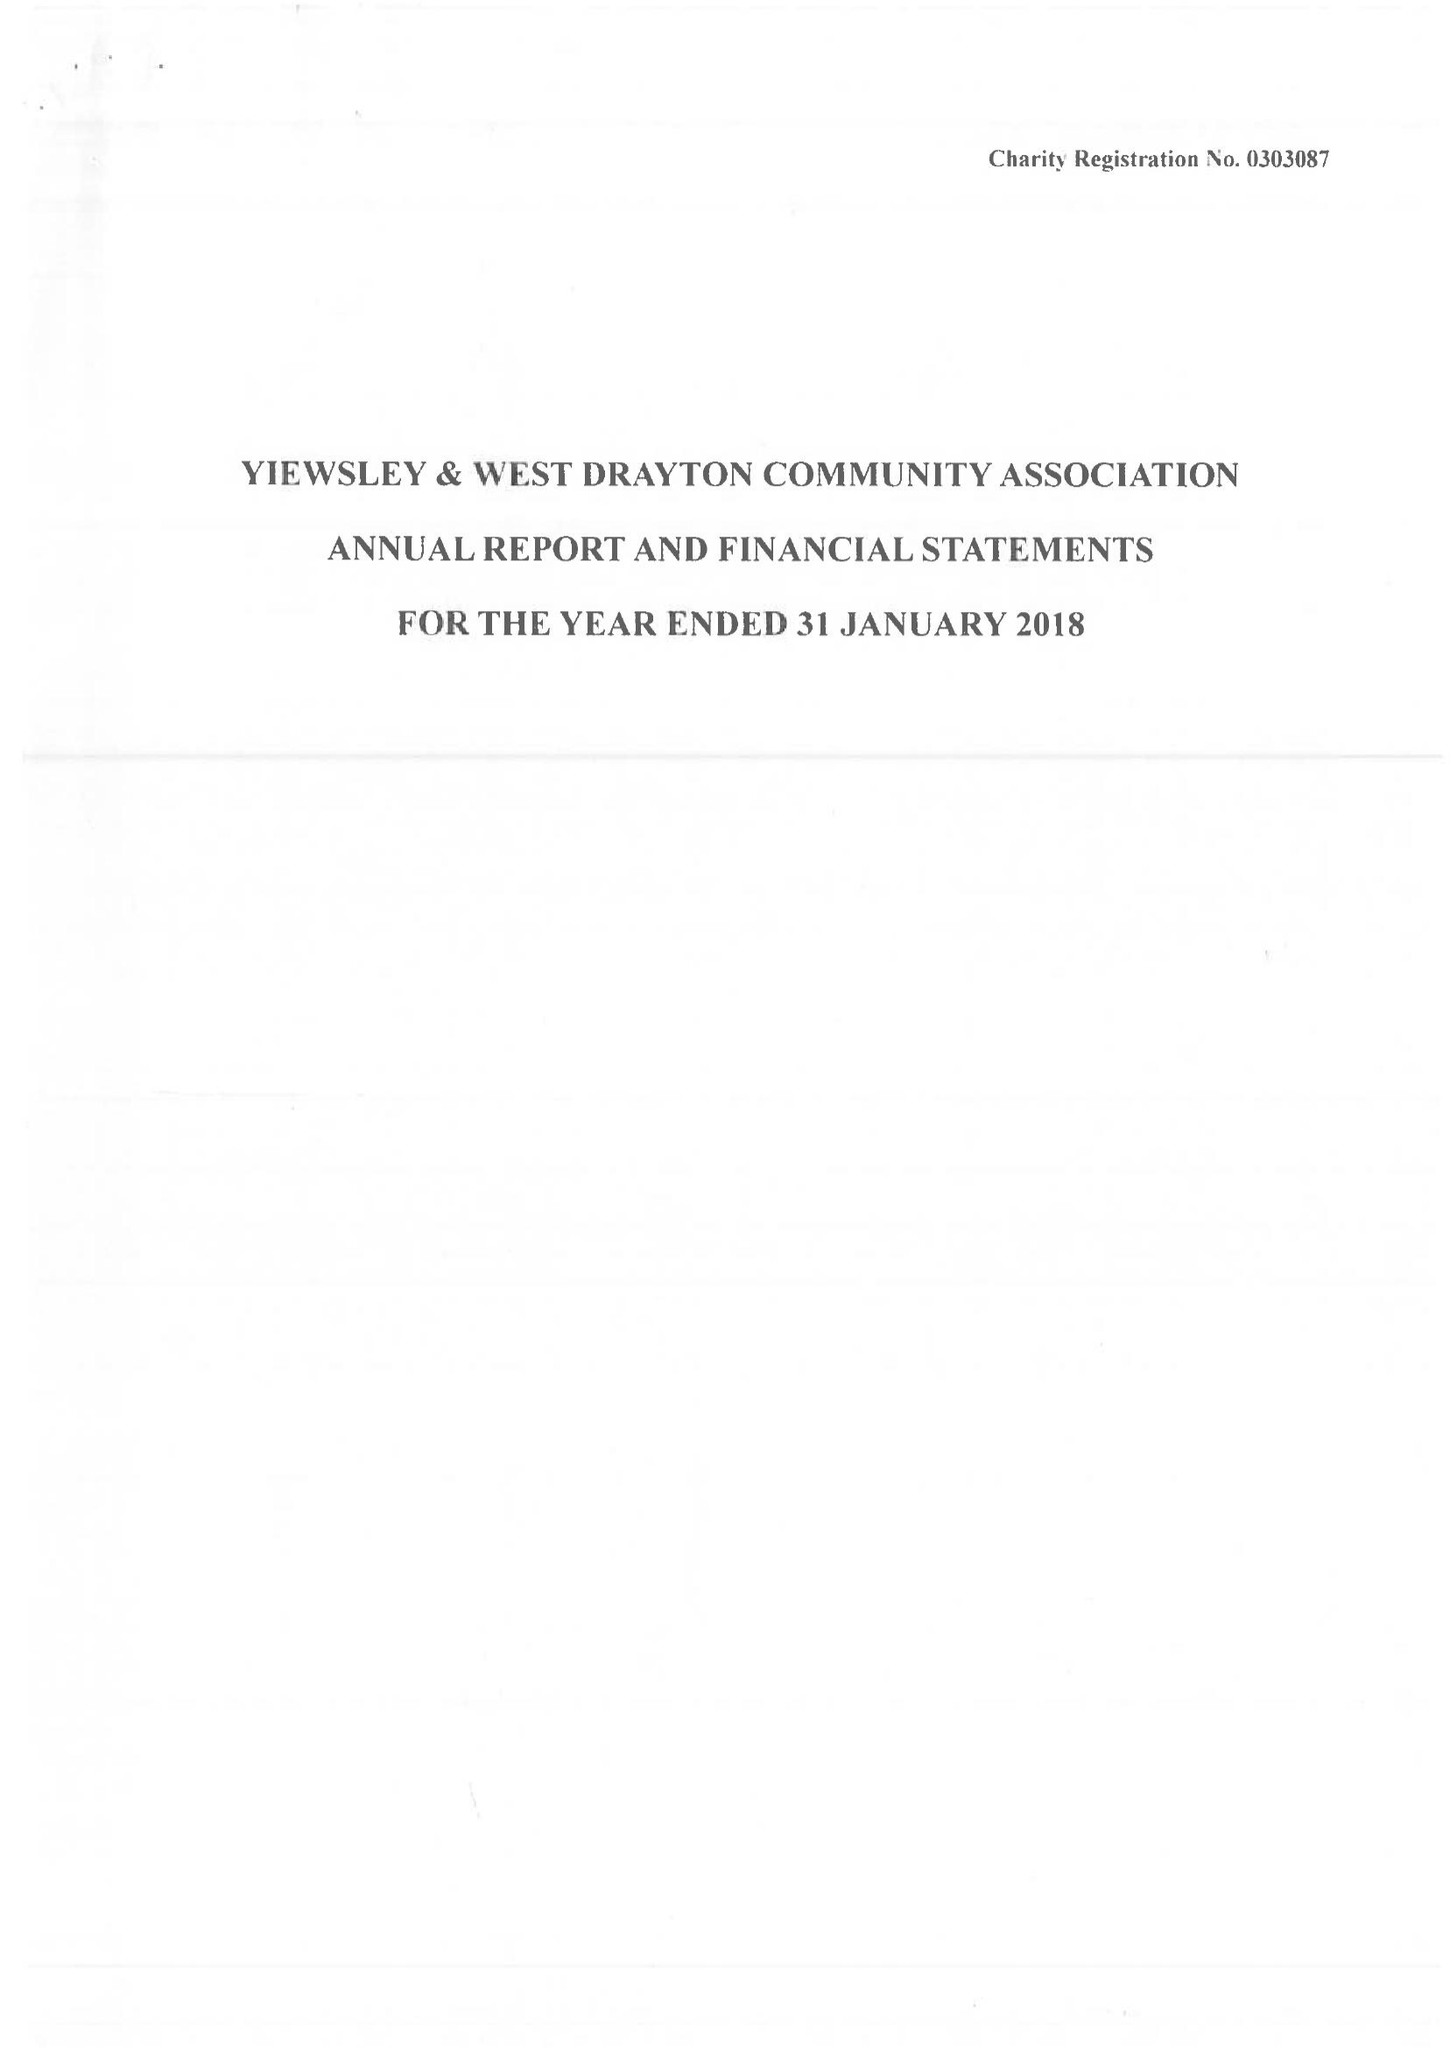What is the value for the charity_number?
Answer the question using a single word or phrase. 303087 